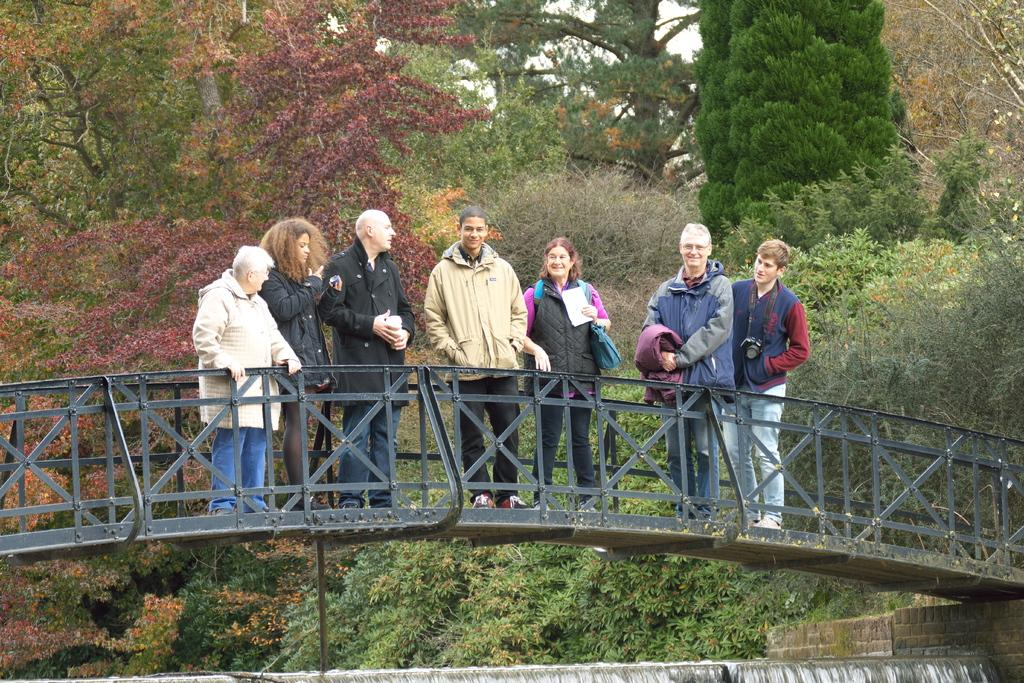How many people are standing on the bridge in the image? There are seven people standing on the bridge in the image. What can be seen in the image besides the people on the bridge? A camera, a bag, a paper, walls, some unspecified objects, and trees in the background are visible in the image. What type of ants can be seen crawling on the paper in the image? There are no ants present in the image, so it is not possible to determine what type of ants might be crawling on the paper. 